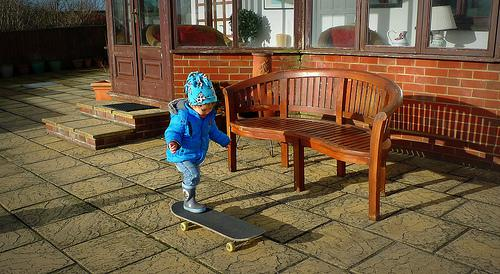Question: what is the building made of?
Choices:
A. Stone.
B. Wood.
C. Metal.
D. Brick.
Answer with the letter. Answer: D Question: where was the picture taken?
Choices:
A. In the mountains.
B. Outside a house.
C. In the middle of a riot.
D. In a temple.
Answer with the letter. Answer: B Question: what color is the chair?
Choices:
A. Green.
B. White.
C. Blue.
D. Brown.
Answer with the letter. Answer: D Question: how many people are in the picture?
Choices:
A. One.
B. Two.
C. Three.
D. Four.
Answer with the letter. Answer: A Question: what is the child doing?
Choices:
A. Riding a bike.
B. Riding a scooter.
C. Riding a skateboard.
D. Rollerskating.
Answer with the letter. Answer: C 